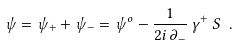Convert formula to latex. <formula><loc_0><loc_0><loc_500><loc_500>\psi = \psi _ { + } + \psi _ { - } = \psi ^ { o } - \frac { 1 } { 2 i \, \partial _ { - } } \, \gamma ^ { + } \, S \ .</formula> 